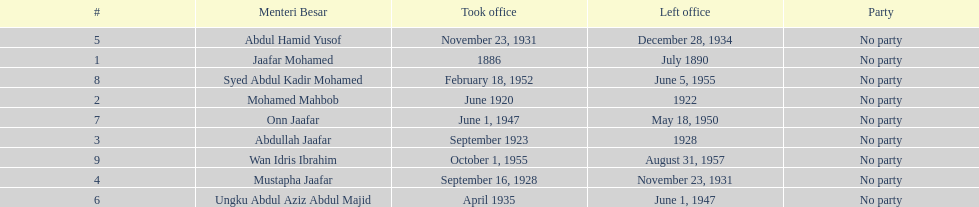Who is listed below onn jaafar? Syed Abdul Kadir Mohamed. 